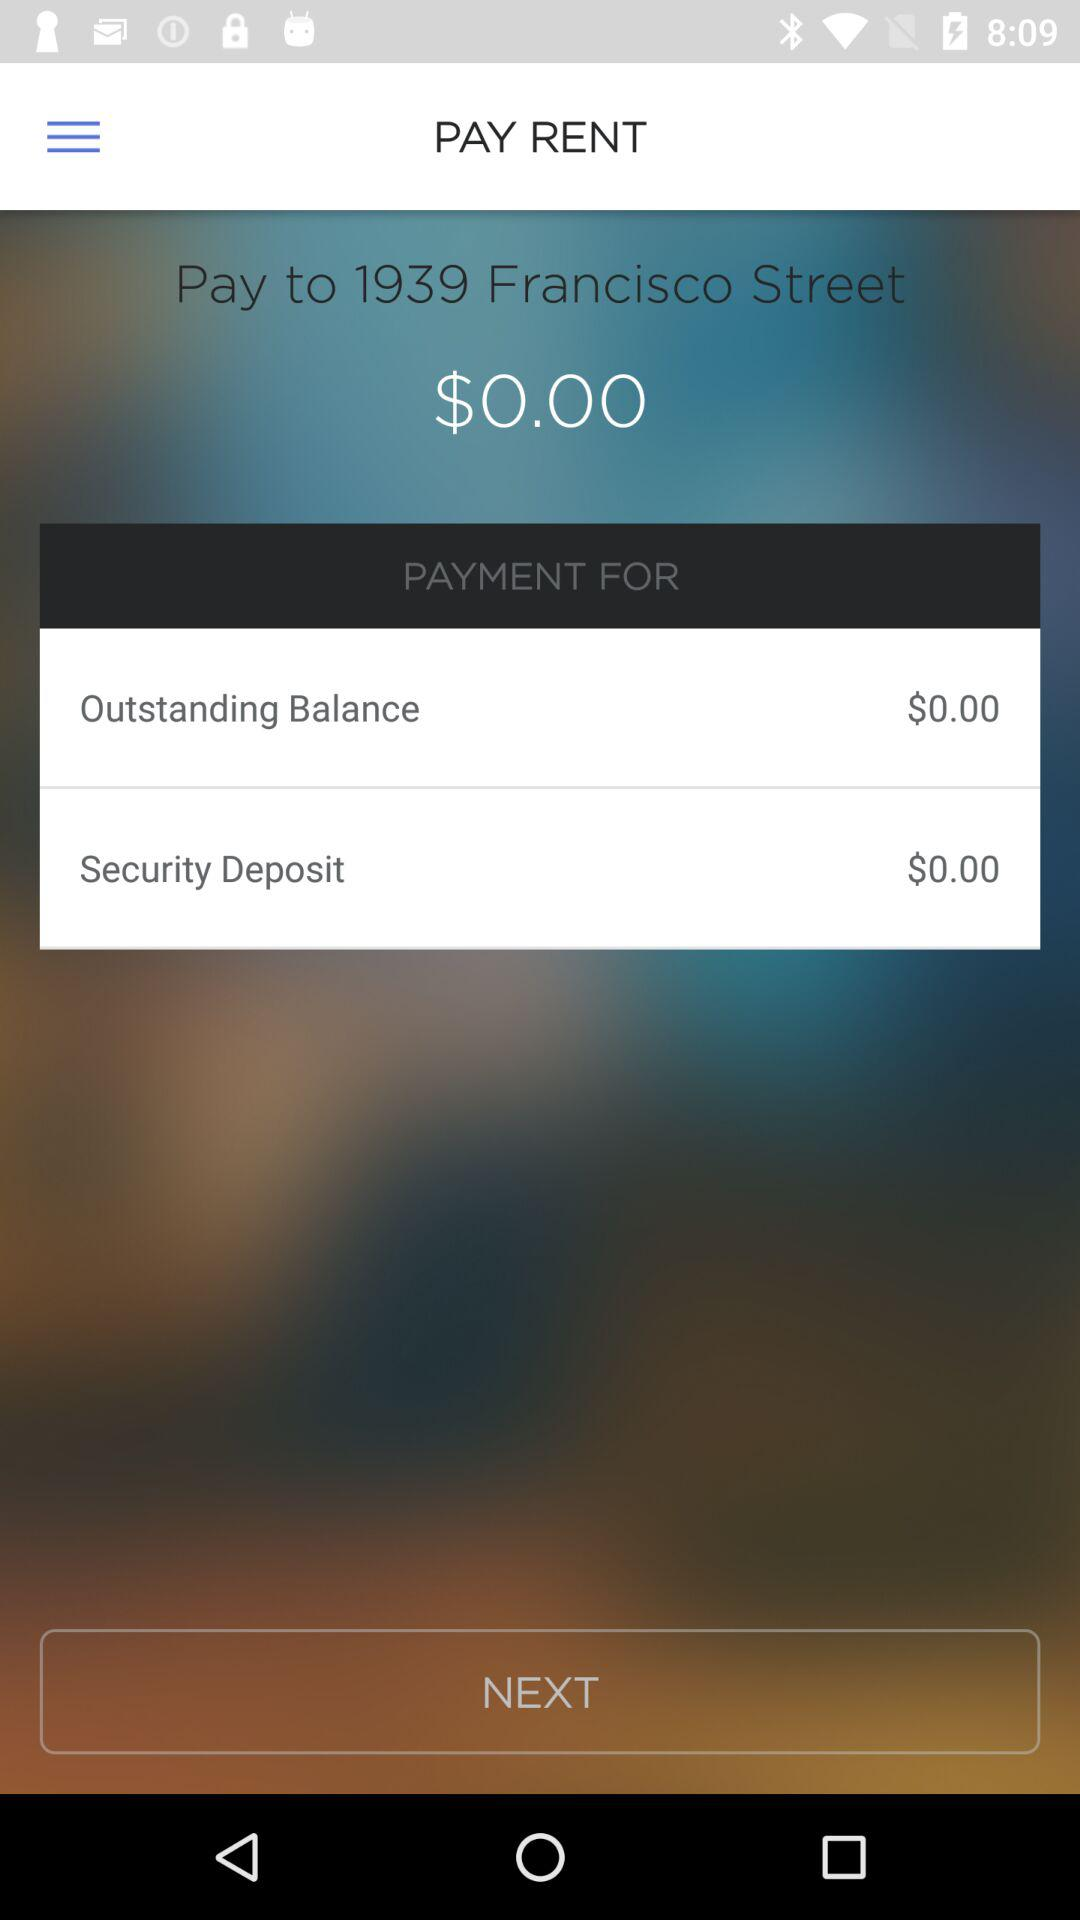How much is the security deposit?
Answer the question using a single word or phrase. $0.00 